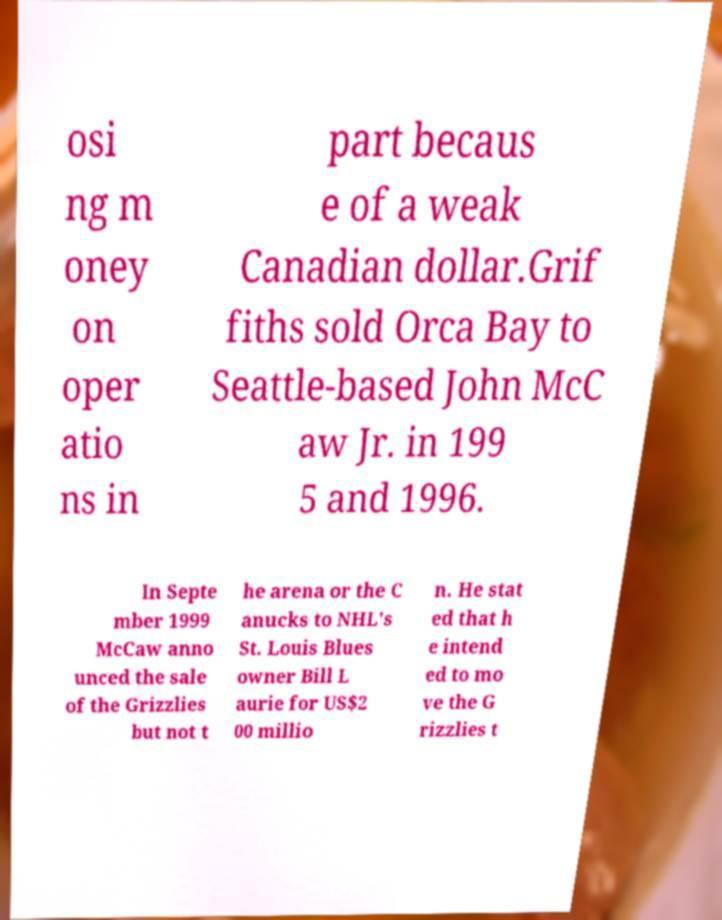Can you accurately transcribe the text from the provided image for me? osi ng m oney on oper atio ns in part becaus e of a weak Canadian dollar.Grif fiths sold Orca Bay to Seattle-based John McC aw Jr. in 199 5 and 1996. In Septe mber 1999 McCaw anno unced the sale of the Grizzlies but not t he arena or the C anucks to NHL's St. Louis Blues owner Bill L aurie for US$2 00 millio n. He stat ed that h e intend ed to mo ve the G rizzlies t 